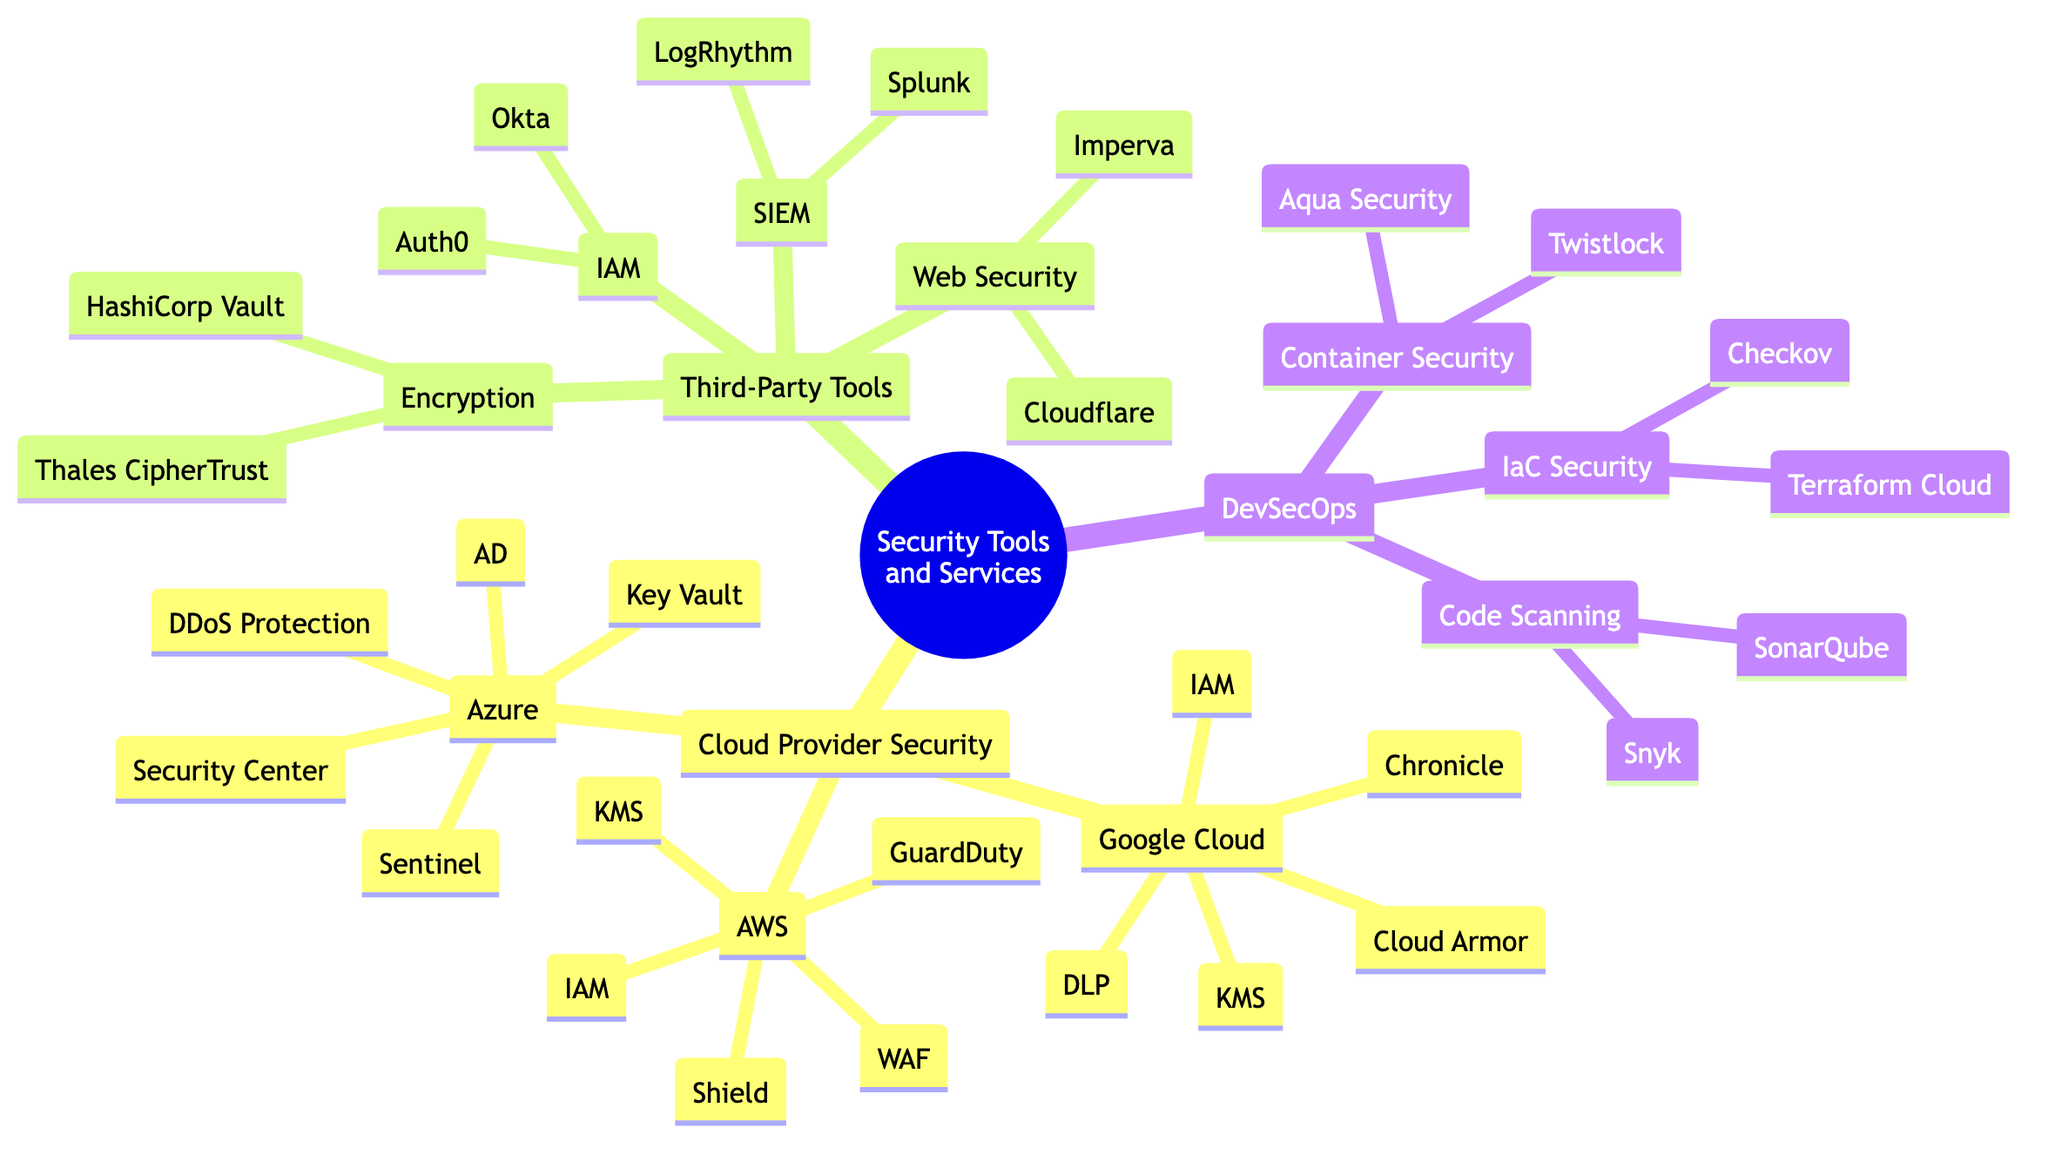What are the three main categories of security tools and services? The diagram shows three main categories under the root: Cloud Provider Security Services, Third-Party Security Tools, and DevSecOps Practices.
Answer: Cloud Provider Security Services, Third-Party Security Tools, DevSecOps Practices How many security services are listed under AWS? Under AWS Security Services, there are five listed services: IAM, KMS, WAF, Shield, and GuardDuty.
Answer: Five Which third-party tool is used for Identity and Access Management? The diagram displays two tools under Identity and Access Management: Auth0 and Okta. Since the question specifies a third-party tool, either can be considered acceptable.
Answer: Auth0 Which cloud provider offers DDoS Protection as a security service? The diagram indicates that Azure Security Services includes DDoS Protection as one of its offerings.
Answer: Azure What is the relationship between Code Scanning and DevSecOps Practices? Code Scanning is a child node under the DevSecOps Practices category, indicating that it is part of the activities associated with DevSecOps.
Answer: Child node How many tools are listed under Encryption and Key Management in Third-Party Security Tools? There are two tools listed under Encryption and Key Management: HashiCorp Vault and Thales CipherTrust.
Answer: Two Which security tool is associated with Container Security in the DevSecOps Practices branch? Aqua Security and Twistlock are both listed under Container Security, indicating their role in this area of DevSecOps Practices.
Answer: Aqua Security (or Twistlock) What is the total number of security services offered by Google Cloud? Google Cloud Security Services lists five unique services: IAM, KMS, Cloud Armor, DLP, and Chronicle, summing up to five.
Answer: Five Which security tool in the diagram is a Web Application Firewall? Among the listed security services under AWS, AWS Web Application Firewall (WAF) is identified as a Web Application Firewall tool.
Answer: AWS Web Application Firewall 